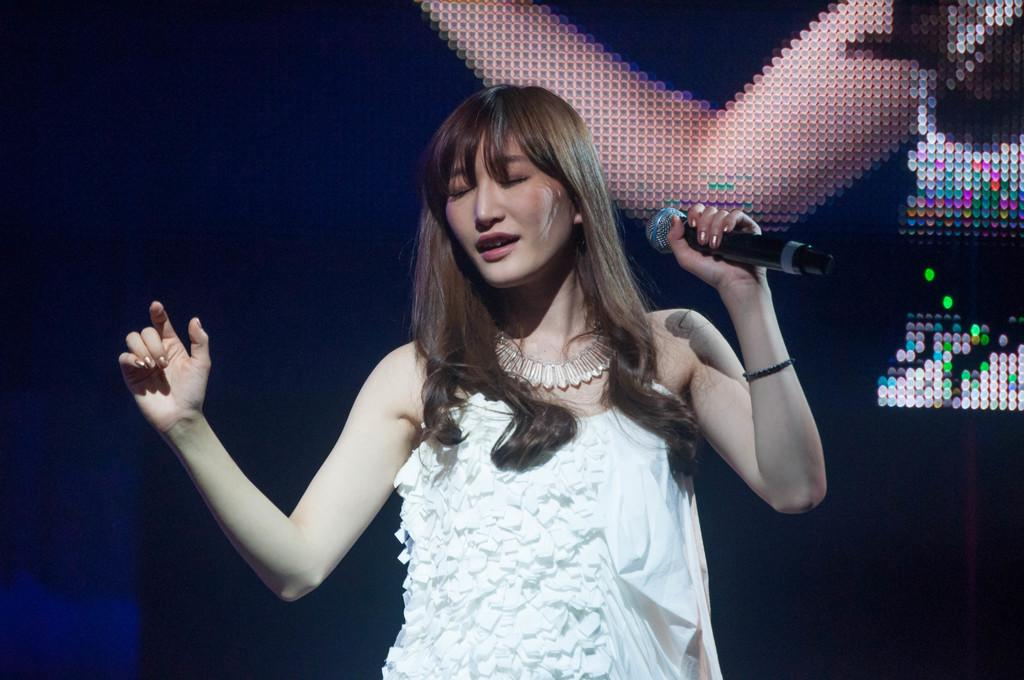What is the main subject of the image? The main subject of the image is a girl. Can you describe the girl's position in the image? The girl is at the center of the image. What is the girl holding in her hand? The girl is holding a mic in her left hand. What type of potato can be seen growing on the hill in the image? There is no potato or hill present in the image; it features a girl holding a mic. Can you tell me how many volcanoes are visible in the image? There are no volcanoes present in the image. 